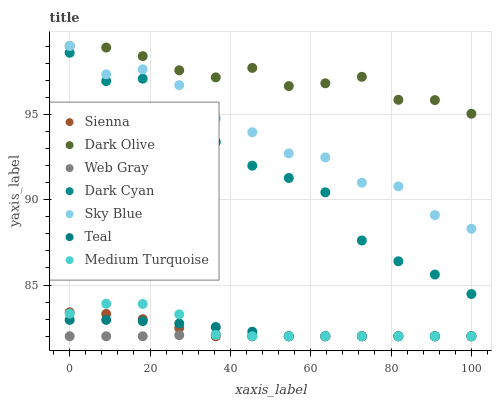Does Web Gray have the minimum area under the curve?
Answer yes or no. Yes. Does Dark Olive have the maximum area under the curve?
Answer yes or no. Yes. Does Medium Turquoise have the minimum area under the curve?
Answer yes or no. No. Does Medium Turquoise have the maximum area under the curve?
Answer yes or no. No. Is Web Gray the smoothest?
Answer yes or no. Yes. Is Sky Blue the roughest?
Answer yes or no. Yes. Is Medium Turquoise the smoothest?
Answer yes or no. No. Is Medium Turquoise the roughest?
Answer yes or no. No. Does Web Gray have the lowest value?
Answer yes or no. Yes. Does Dark Olive have the lowest value?
Answer yes or no. No. Does Sky Blue have the highest value?
Answer yes or no. Yes. Does Medium Turquoise have the highest value?
Answer yes or no. No. Is Medium Turquoise less than Sky Blue?
Answer yes or no. Yes. Is Sky Blue greater than Dark Cyan?
Answer yes or no. Yes. Does Sienna intersect Web Gray?
Answer yes or no. Yes. Is Sienna less than Web Gray?
Answer yes or no. No. Is Sienna greater than Web Gray?
Answer yes or no. No. Does Medium Turquoise intersect Sky Blue?
Answer yes or no. No. 